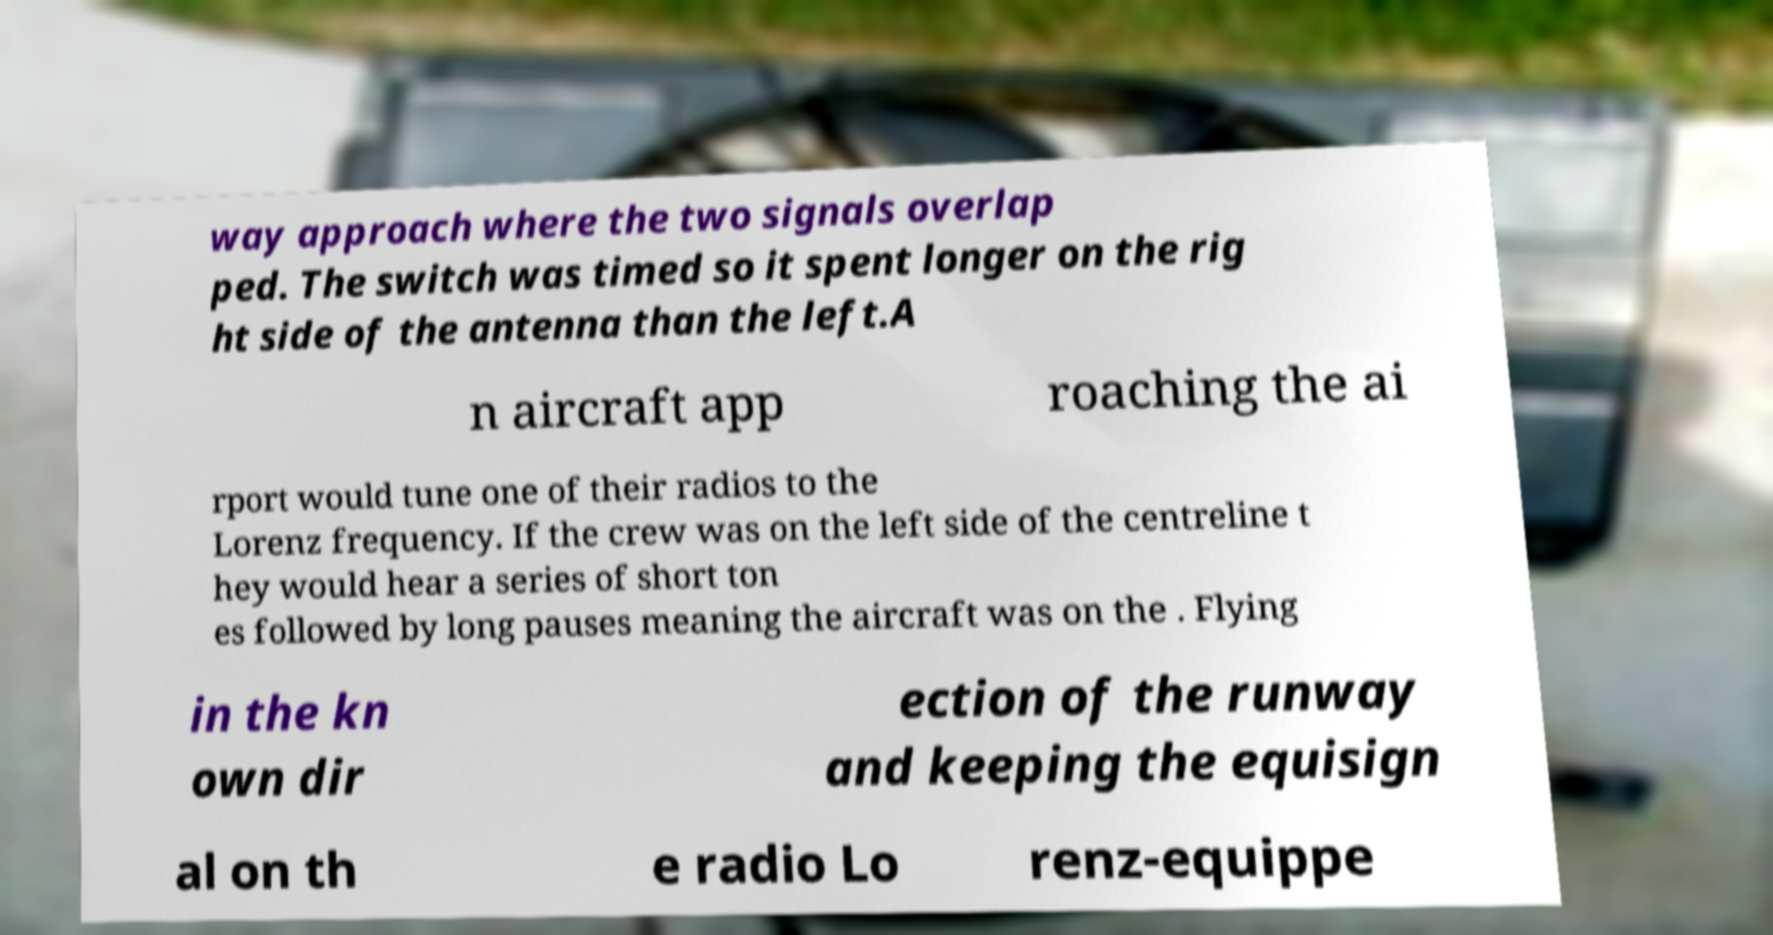Can you accurately transcribe the text from the provided image for me? way approach where the two signals overlap ped. The switch was timed so it spent longer on the rig ht side of the antenna than the left.A n aircraft app roaching the ai rport would tune one of their radios to the Lorenz frequency. If the crew was on the left side of the centreline t hey would hear a series of short ton es followed by long pauses meaning the aircraft was on the . Flying in the kn own dir ection of the runway and keeping the equisign al on th e radio Lo renz-equippe 